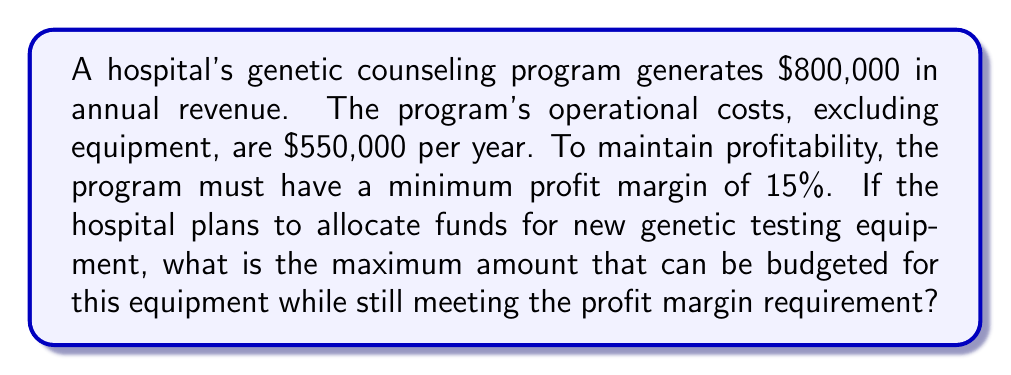Show me your answer to this math problem. Let's approach this step-by-step:

1) First, let's define our variables:
   $R$ = Annual revenue = $800,000
   $C$ = Operational costs = $550,000
   $x$ = Maximum budget for equipment
   
2) The profit margin is defined as:
   $\text{Profit Margin} = \frac{\text{Profit}}{\text{Revenue}} \times 100\%$

3) We know the profit margin must be at least 15%. This can be expressed as:
   $$\frac{R - (C + x)}{R} \geq 0.15$$

4) Substituting our known values:
   $$\frac{800,000 - (550,000 + x)}{800,000} \geq 0.15$$

5) Simplify:
   $$\frac{250,000 - x}{800,000} \geq 0.15$$

6) Multiply both sides by 800,000:
   $$250,000 - x \geq 120,000$$

7) Subtract 250,000 from both sides:
   $$-x \geq -130,000$$

8) Multiply both sides by -1 (and flip the inequality sign):
   $$x \leq 130,000$$

Therefore, the maximum budget for the equipment while maintaining the required profit margin is $130,000.
Answer: $130,000 